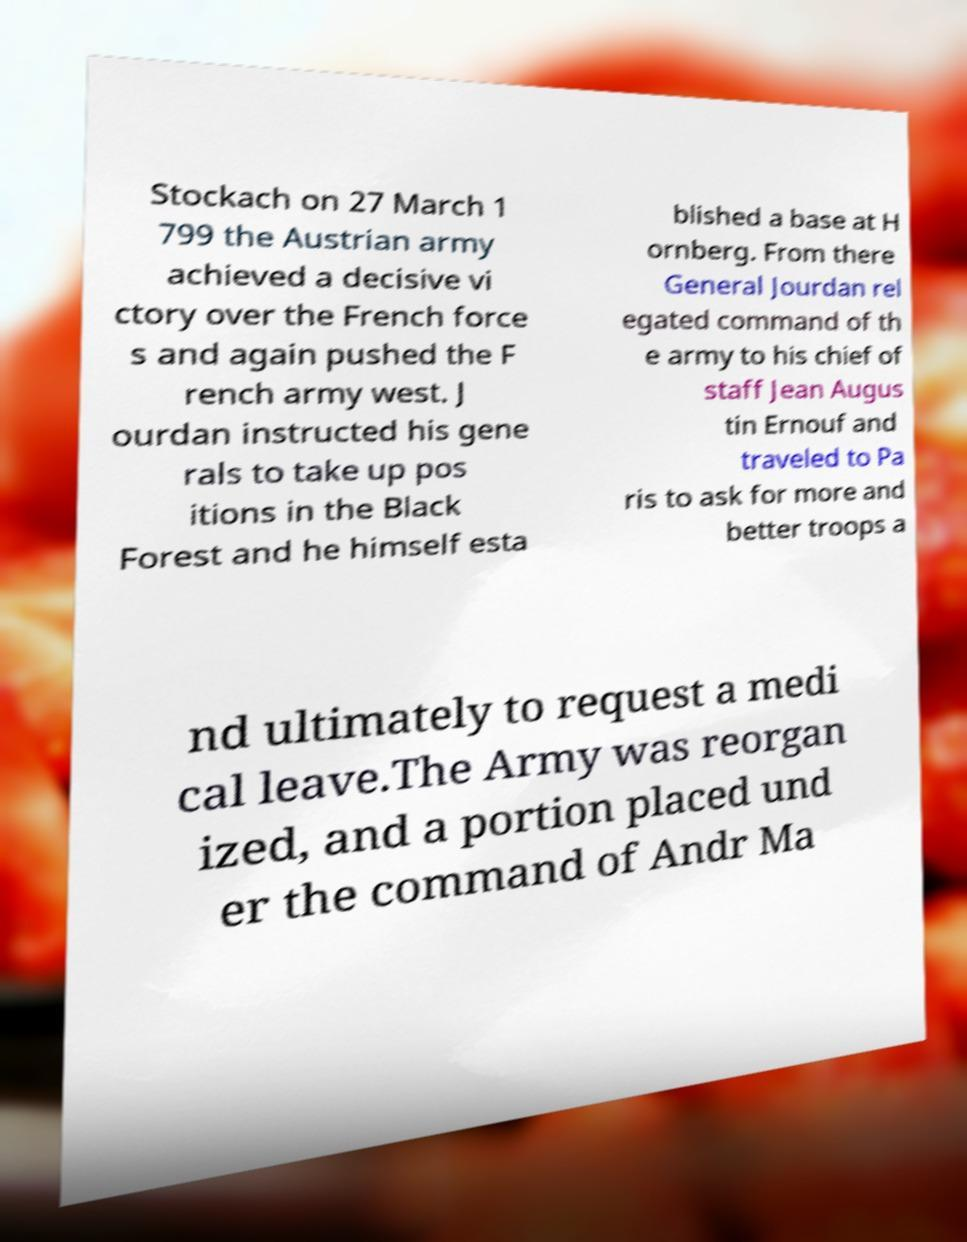What messages or text are displayed in this image? I need them in a readable, typed format. Stockach on 27 March 1 799 the Austrian army achieved a decisive vi ctory over the French force s and again pushed the F rench army west. J ourdan instructed his gene rals to take up pos itions in the Black Forest and he himself esta blished a base at H ornberg. From there General Jourdan rel egated command of th e army to his chief of staff Jean Augus tin Ernouf and traveled to Pa ris to ask for more and better troops a nd ultimately to request a medi cal leave.The Army was reorgan ized, and a portion placed und er the command of Andr Ma 